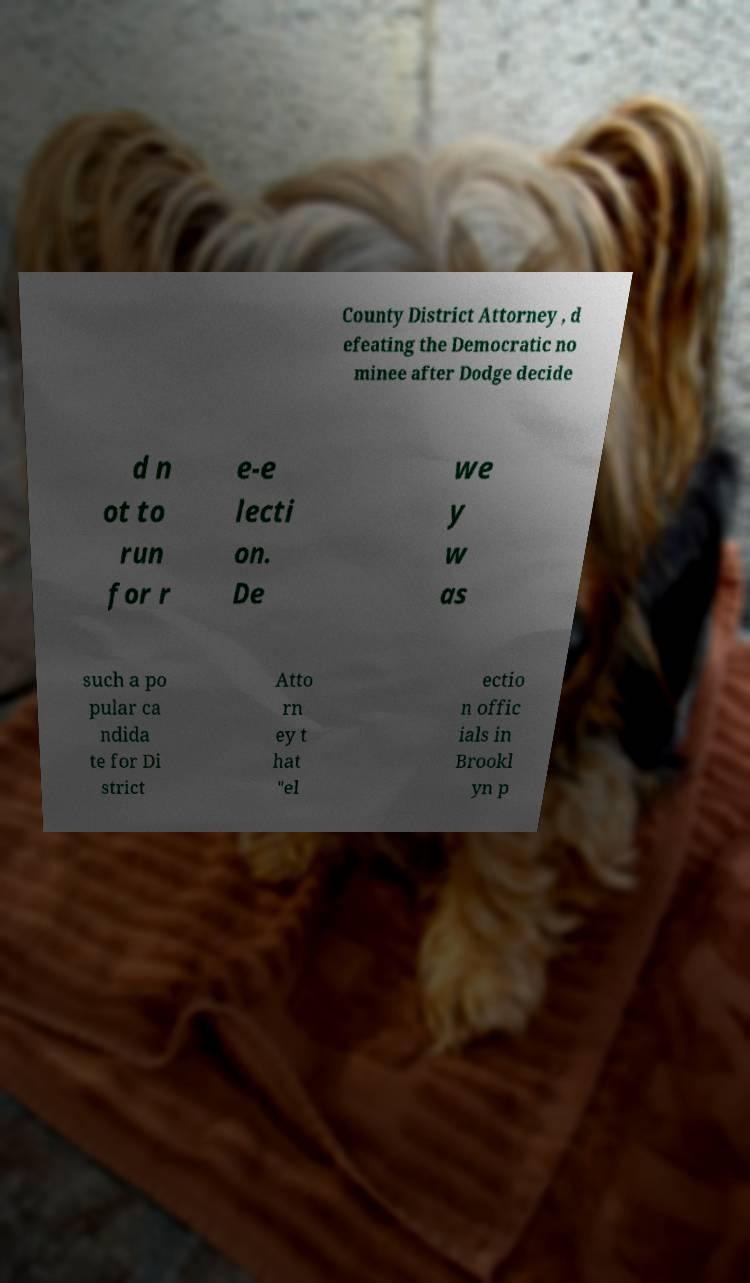I need the written content from this picture converted into text. Can you do that? County District Attorney , d efeating the Democratic no minee after Dodge decide d n ot to run for r e-e lecti on. De we y w as such a po pular ca ndida te for Di strict Atto rn ey t hat "el ectio n offic ials in Brookl yn p 